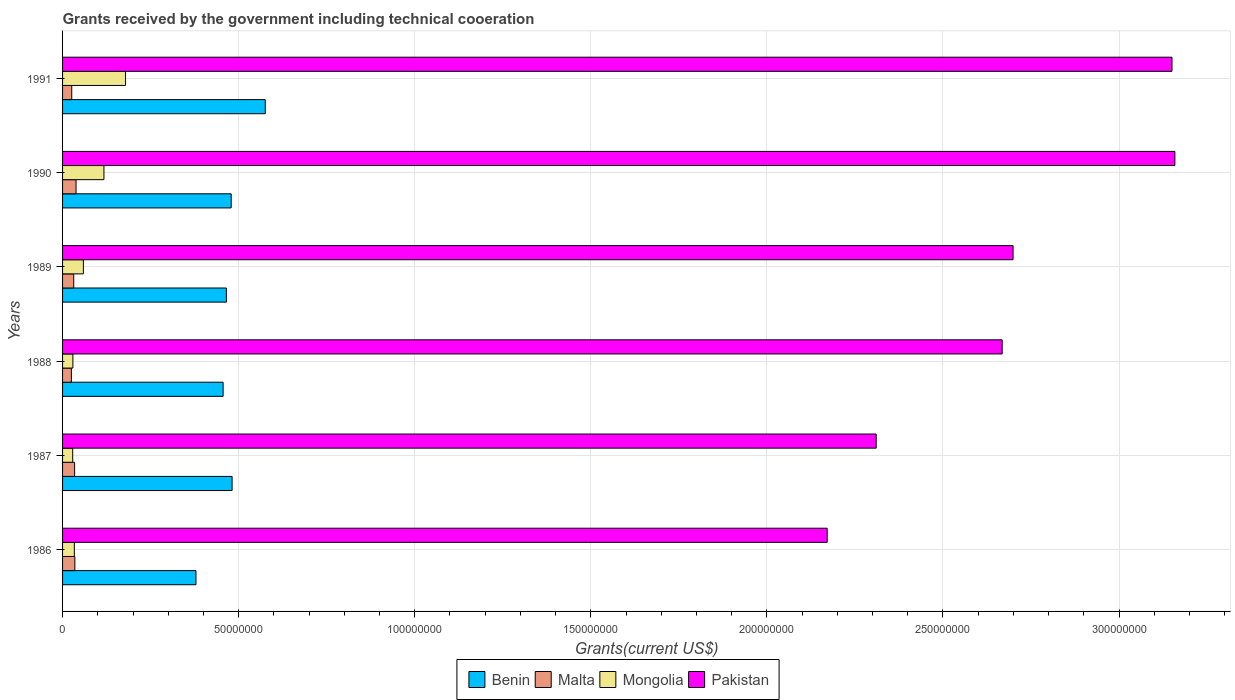How many different coloured bars are there?
Offer a terse response. 4. Are the number of bars per tick equal to the number of legend labels?
Your response must be concise. Yes. How many bars are there on the 4th tick from the top?
Make the answer very short. 4. In how many cases, is the number of bars for a given year not equal to the number of legend labels?
Your response must be concise. 0. What is the total grants received by the government in Pakistan in 1989?
Give a very brief answer. 2.70e+08. Across all years, what is the maximum total grants received by the government in Pakistan?
Ensure brevity in your answer.  3.16e+08. Across all years, what is the minimum total grants received by the government in Malta?
Ensure brevity in your answer.  2.50e+06. In which year was the total grants received by the government in Mongolia minimum?
Keep it short and to the point. 1987. What is the total total grants received by the government in Pakistan in the graph?
Give a very brief answer. 1.62e+09. What is the difference between the total grants received by the government in Benin in 1988 and that in 1990?
Provide a succinct answer. -2.29e+06. What is the difference between the total grants received by the government in Mongolia in 1987 and the total grants received by the government in Pakistan in 1991?
Provide a succinct answer. -3.12e+08. What is the average total grants received by the government in Benin per year?
Your answer should be compact. 4.73e+07. In the year 1991, what is the difference between the total grants received by the government in Malta and total grants received by the government in Mongolia?
Make the answer very short. -1.53e+07. In how many years, is the total grants received by the government in Benin greater than 230000000 US$?
Your answer should be compact. 0. What is the ratio of the total grants received by the government in Benin in 1988 to that in 1991?
Provide a short and direct response. 0.79. What is the difference between the highest and the second highest total grants received by the government in Mongolia?
Give a very brief answer. 6.13e+06. What is the difference between the highest and the lowest total grants received by the government in Benin?
Offer a terse response. 1.97e+07. Is the sum of the total grants received by the government in Pakistan in 1988 and 1989 greater than the maximum total grants received by the government in Malta across all years?
Offer a terse response. Yes. Is it the case that in every year, the sum of the total grants received by the government in Malta and total grants received by the government in Benin is greater than the sum of total grants received by the government in Pakistan and total grants received by the government in Mongolia?
Offer a very short reply. Yes. What does the 4th bar from the top in 1986 represents?
Ensure brevity in your answer.  Benin. What does the 3rd bar from the bottom in 1988 represents?
Provide a short and direct response. Mongolia. Are the values on the major ticks of X-axis written in scientific E-notation?
Give a very brief answer. No. Does the graph contain grids?
Your response must be concise. Yes. What is the title of the graph?
Your answer should be compact. Grants received by the government including technical cooeration. What is the label or title of the X-axis?
Your answer should be compact. Grants(current US$). What is the Grants(current US$) of Benin in 1986?
Your answer should be very brief. 3.79e+07. What is the Grants(current US$) in Malta in 1986?
Keep it short and to the point. 3.49e+06. What is the Grants(current US$) of Mongolia in 1986?
Ensure brevity in your answer.  3.34e+06. What is the Grants(current US$) of Pakistan in 1986?
Your answer should be very brief. 2.17e+08. What is the Grants(current US$) of Benin in 1987?
Keep it short and to the point. 4.81e+07. What is the Grants(current US$) in Malta in 1987?
Ensure brevity in your answer.  3.42e+06. What is the Grants(current US$) of Mongolia in 1987?
Your response must be concise. 2.88e+06. What is the Grants(current US$) in Pakistan in 1987?
Offer a very short reply. 2.31e+08. What is the Grants(current US$) of Benin in 1988?
Offer a very short reply. 4.56e+07. What is the Grants(current US$) in Malta in 1988?
Your answer should be compact. 2.50e+06. What is the Grants(current US$) of Mongolia in 1988?
Provide a succinct answer. 2.93e+06. What is the Grants(current US$) in Pakistan in 1988?
Your answer should be compact. 2.67e+08. What is the Grants(current US$) of Benin in 1989?
Ensure brevity in your answer.  4.65e+07. What is the Grants(current US$) in Malta in 1989?
Your answer should be compact. 3.17e+06. What is the Grants(current US$) in Mongolia in 1989?
Give a very brief answer. 5.91e+06. What is the Grants(current US$) of Pakistan in 1989?
Provide a short and direct response. 2.70e+08. What is the Grants(current US$) in Benin in 1990?
Give a very brief answer. 4.79e+07. What is the Grants(current US$) in Malta in 1990?
Make the answer very short. 3.83e+06. What is the Grants(current US$) of Mongolia in 1990?
Give a very brief answer. 1.18e+07. What is the Grants(current US$) of Pakistan in 1990?
Provide a succinct answer. 3.16e+08. What is the Grants(current US$) in Benin in 1991?
Offer a terse response. 5.76e+07. What is the Grants(current US$) of Malta in 1991?
Your answer should be very brief. 2.61e+06. What is the Grants(current US$) of Mongolia in 1991?
Make the answer very short. 1.79e+07. What is the Grants(current US$) of Pakistan in 1991?
Offer a terse response. 3.15e+08. Across all years, what is the maximum Grants(current US$) of Benin?
Provide a short and direct response. 5.76e+07. Across all years, what is the maximum Grants(current US$) in Malta?
Offer a terse response. 3.83e+06. Across all years, what is the maximum Grants(current US$) of Mongolia?
Your response must be concise. 1.79e+07. Across all years, what is the maximum Grants(current US$) of Pakistan?
Give a very brief answer. 3.16e+08. Across all years, what is the minimum Grants(current US$) in Benin?
Provide a short and direct response. 3.79e+07. Across all years, what is the minimum Grants(current US$) of Malta?
Make the answer very short. 2.50e+06. Across all years, what is the minimum Grants(current US$) of Mongolia?
Keep it short and to the point. 2.88e+06. Across all years, what is the minimum Grants(current US$) in Pakistan?
Provide a short and direct response. 2.17e+08. What is the total Grants(current US$) of Benin in the graph?
Provide a short and direct response. 2.84e+08. What is the total Grants(current US$) in Malta in the graph?
Make the answer very short. 1.90e+07. What is the total Grants(current US$) in Mongolia in the graph?
Offer a terse response. 4.47e+07. What is the total Grants(current US$) in Pakistan in the graph?
Give a very brief answer. 1.62e+09. What is the difference between the Grants(current US$) in Benin in 1986 and that in 1987?
Make the answer very short. -1.03e+07. What is the difference between the Grants(current US$) of Malta in 1986 and that in 1987?
Ensure brevity in your answer.  7.00e+04. What is the difference between the Grants(current US$) in Mongolia in 1986 and that in 1987?
Provide a short and direct response. 4.60e+05. What is the difference between the Grants(current US$) of Pakistan in 1986 and that in 1987?
Keep it short and to the point. -1.39e+07. What is the difference between the Grants(current US$) in Benin in 1986 and that in 1988?
Your answer should be compact. -7.71e+06. What is the difference between the Grants(current US$) in Malta in 1986 and that in 1988?
Offer a terse response. 9.90e+05. What is the difference between the Grants(current US$) of Pakistan in 1986 and that in 1988?
Make the answer very short. -4.97e+07. What is the difference between the Grants(current US$) of Benin in 1986 and that in 1989?
Offer a very short reply. -8.63e+06. What is the difference between the Grants(current US$) in Mongolia in 1986 and that in 1989?
Offer a very short reply. -2.57e+06. What is the difference between the Grants(current US$) of Pakistan in 1986 and that in 1989?
Your response must be concise. -5.28e+07. What is the difference between the Grants(current US$) in Benin in 1986 and that in 1990?
Offer a very short reply. -1.00e+07. What is the difference between the Grants(current US$) in Malta in 1986 and that in 1990?
Make the answer very short. -3.40e+05. What is the difference between the Grants(current US$) in Mongolia in 1986 and that in 1990?
Your response must be concise. -8.41e+06. What is the difference between the Grants(current US$) in Pakistan in 1986 and that in 1990?
Your answer should be very brief. -9.87e+07. What is the difference between the Grants(current US$) of Benin in 1986 and that in 1991?
Ensure brevity in your answer.  -1.97e+07. What is the difference between the Grants(current US$) of Malta in 1986 and that in 1991?
Your answer should be compact. 8.80e+05. What is the difference between the Grants(current US$) in Mongolia in 1986 and that in 1991?
Your answer should be very brief. -1.45e+07. What is the difference between the Grants(current US$) of Pakistan in 1986 and that in 1991?
Your answer should be compact. -9.79e+07. What is the difference between the Grants(current US$) of Benin in 1987 and that in 1988?
Keep it short and to the point. 2.55e+06. What is the difference between the Grants(current US$) of Malta in 1987 and that in 1988?
Give a very brief answer. 9.20e+05. What is the difference between the Grants(current US$) of Mongolia in 1987 and that in 1988?
Give a very brief answer. -5.00e+04. What is the difference between the Grants(current US$) of Pakistan in 1987 and that in 1988?
Offer a very short reply. -3.58e+07. What is the difference between the Grants(current US$) in Benin in 1987 and that in 1989?
Keep it short and to the point. 1.63e+06. What is the difference between the Grants(current US$) in Malta in 1987 and that in 1989?
Provide a short and direct response. 2.50e+05. What is the difference between the Grants(current US$) of Mongolia in 1987 and that in 1989?
Give a very brief answer. -3.03e+06. What is the difference between the Grants(current US$) in Pakistan in 1987 and that in 1989?
Offer a terse response. -3.89e+07. What is the difference between the Grants(current US$) of Benin in 1987 and that in 1990?
Offer a terse response. 2.60e+05. What is the difference between the Grants(current US$) of Malta in 1987 and that in 1990?
Your answer should be compact. -4.10e+05. What is the difference between the Grants(current US$) of Mongolia in 1987 and that in 1990?
Provide a short and direct response. -8.87e+06. What is the difference between the Grants(current US$) in Pakistan in 1987 and that in 1990?
Offer a very short reply. -8.48e+07. What is the difference between the Grants(current US$) in Benin in 1987 and that in 1991?
Your answer should be very brief. -9.42e+06. What is the difference between the Grants(current US$) of Malta in 1987 and that in 1991?
Keep it short and to the point. 8.10e+05. What is the difference between the Grants(current US$) of Mongolia in 1987 and that in 1991?
Provide a succinct answer. -1.50e+07. What is the difference between the Grants(current US$) of Pakistan in 1987 and that in 1991?
Provide a short and direct response. -8.40e+07. What is the difference between the Grants(current US$) of Benin in 1988 and that in 1989?
Ensure brevity in your answer.  -9.20e+05. What is the difference between the Grants(current US$) in Malta in 1988 and that in 1989?
Keep it short and to the point. -6.70e+05. What is the difference between the Grants(current US$) in Mongolia in 1988 and that in 1989?
Your response must be concise. -2.98e+06. What is the difference between the Grants(current US$) in Pakistan in 1988 and that in 1989?
Make the answer very short. -3.09e+06. What is the difference between the Grants(current US$) in Benin in 1988 and that in 1990?
Ensure brevity in your answer.  -2.29e+06. What is the difference between the Grants(current US$) of Malta in 1988 and that in 1990?
Offer a terse response. -1.33e+06. What is the difference between the Grants(current US$) of Mongolia in 1988 and that in 1990?
Your answer should be compact. -8.82e+06. What is the difference between the Grants(current US$) in Pakistan in 1988 and that in 1990?
Your answer should be very brief. -4.90e+07. What is the difference between the Grants(current US$) of Benin in 1988 and that in 1991?
Offer a terse response. -1.20e+07. What is the difference between the Grants(current US$) in Malta in 1988 and that in 1991?
Keep it short and to the point. -1.10e+05. What is the difference between the Grants(current US$) in Mongolia in 1988 and that in 1991?
Your answer should be compact. -1.50e+07. What is the difference between the Grants(current US$) in Pakistan in 1988 and that in 1991?
Your answer should be compact. -4.82e+07. What is the difference between the Grants(current US$) in Benin in 1989 and that in 1990?
Provide a short and direct response. -1.37e+06. What is the difference between the Grants(current US$) in Malta in 1989 and that in 1990?
Make the answer very short. -6.60e+05. What is the difference between the Grants(current US$) in Mongolia in 1989 and that in 1990?
Offer a very short reply. -5.84e+06. What is the difference between the Grants(current US$) in Pakistan in 1989 and that in 1990?
Provide a short and direct response. -4.60e+07. What is the difference between the Grants(current US$) of Benin in 1989 and that in 1991?
Provide a succinct answer. -1.10e+07. What is the difference between the Grants(current US$) in Malta in 1989 and that in 1991?
Offer a very short reply. 5.60e+05. What is the difference between the Grants(current US$) in Mongolia in 1989 and that in 1991?
Offer a very short reply. -1.20e+07. What is the difference between the Grants(current US$) in Pakistan in 1989 and that in 1991?
Offer a very short reply. -4.51e+07. What is the difference between the Grants(current US$) in Benin in 1990 and that in 1991?
Make the answer very short. -9.68e+06. What is the difference between the Grants(current US$) in Malta in 1990 and that in 1991?
Your answer should be compact. 1.22e+06. What is the difference between the Grants(current US$) in Mongolia in 1990 and that in 1991?
Your answer should be compact. -6.13e+06. What is the difference between the Grants(current US$) in Pakistan in 1990 and that in 1991?
Give a very brief answer. 8.20e+05. What is the difference between the Grants(current US$) of Benin in 1986 and the Grants(current US$) of Malta in 1987?
Make the answer very short. 3.45e+07. What is the difference between the Grants(current US$) of Benin in 1986 and the Grants(current US$) of Mongolia in 1987?
Make the answer very short. 3.50e+07. What is the difference between the Grants(current US$) in Benin in 1986 and the Grants(current US$) in Pakistan in 1987?
Provide a short and direct response. -1.93e+08. What is the difference between the Grants(current US$) in Malta in 1986 and the Grants(current US$) in Mongolia in 1987?
Your response must be concise. 6.10e+05. What is the difference between the Grants(current US$) of Malta in 1986 and the Grants(current US$) of Pakistan in 1987?
Provide a succinct answer. -2.28e+08. What is the difference between the Grants(current US$) in Mongolia in 1986 and the Grants(current US$) in Pakistan in 1987?
Ensure brevity in your answer.  -2.28e+08. What is the difference between the Grants(current US$) of Benin in 1986 and the Grants(current US$) of Malta in 1988?
Provide a short and direct response. 3.54e+07. What is the difference between the Grants(current US$) of Benin in 1986 and the Grants(current US$) of Mongolia in 1988?
Provide a succinct answer. 3.50e+07. What is the difference between the Grants(current US$) of Benin in 1986 and the Grants(current US$) of Pakistan in 1988?
Provide a short and direct response. -2.29e+08. What is the difference between the Grants(current US$) of Malta in 1986 and the Grants(current US$) of Mongolia in 1988?
Your answer should be very brief. 5.60e+05. What is the difference between the Grants(current US$) in Malta in 1986 and the Grants(current US$) in Pakistan in 1988?
Offer a terse response. -2.63e+08. What is the difference between the Grants(current US$) of Mongolia in 1986 and the Grants(current US$) of Pakistan in 1988?
Make the answer very short. -2.63e+08. What is the difference between the Grants(current US$) in Benin in 1986 and the Grants(current US$) in Malta in 1989?
Offer a very short reply. 3.47e+07. What is the difference between the Grants(current US$) of Benin in 1986 and the Grants(current US$) of Mongolia in 1989?
Offer a very short reply. 3.20e+07. What is the difference between the Grants(current US$) of Benin in 1986 and the Grants(current US$) of Pakistan in 1989?
Provide a succinct answer. -2.32e+08. What is the difference between the Grants(current US$) of Malta in 1986 and the Grants(current US$) of Mongolia in 1989?
Give a very brief answer. -2.42e+06. What is the difference between the Grants(current US$) in Malta in 1986 and the Grants(current US$) in Pakistan in 1989?
Provide a short and direct response. -2.66e+08. What is the difference between the Grants(current US$) in Mongolia in 1986 and the Grants(current US$) in Pakistan in 1989?
Your answer should be compact. -2.67e+08. What is the difference between the Grants(current US$) of Benin in 1986 and the Grants(current US$) of Malta in 1990?
Offer a very short reply. 3.40e+07. What is the difference between the Grants(current US$) of Benin in 1986 and the Grants(current US$) of Mongolia in 1990?
Provide a succinct answer. 2.61e+07. What is the difference between the Grants(current US$) of Benin in 1986 and the Grants(current US$) of Pakistan in 1990?
Ensure brevity in your answer.  -2.78e+08. What is the difference between the Grants(current US$) in Malta in 1986 and the Grants(current US$) in Mongolia in 1990?
Ensure brevity in your answer.  -8.26e+06. What is the difference between the Grants(current US$) of Malta in 1986 and the Grants(current US$) of Pakistan in 1990?
Offer a terse response. -3.12e+08. What is the difference between the Grants(current US$) of Mongolia in 1986 and the Grants(current US$) of Pakistan in 1990?
Your response must be concise. -3.13e+08. What is the difference between the Grants(current US$) of Benin in 1986 and the Grants(current US$) of Malta in 1991?
Your response must be concise. 3.53e+07. What is the difference between the Grants(current US$) in Benin in 1986 and the Grants(current US$) in Mongolia in 1991?
Your answer should be compact. 2.00e+07. What is the difference between the Grants(current US$) in Benin in 1986 and the Grants(current US$) in Pakistan in 1991?
Give a very brief answer. -2.77e+08. What is the difference between the Grants(current US$) of Malta in 1986 and the Grants(current US$) of Mongolia in 1991?
Give a very brief answer. -1.44e+07. What is the difference between the Grants(current US$) in Malta in 1986 and the Grants(current US$) in Pakistan in 1991?
Provide a short and direct response. -3.12e+08. What is the difference between the Grants(current US$) of Mongolia in 1986 and the Grants(current US$) of Pakistan in 1991?
Give a very brief answer. -3.12e+08. What is the difference between the Grants(current US$) of Benin in 1987 and the Grants(current US$) of Malta in 1988?
Your answer should be compact. 4.56e+07. What is the difference between the Grants(current US$) in Benin in 1987 and the Grants(current US$) in Mongolia in 1988?
Your answer should be compact. 4.52e+07. What is the difference between the Grants(current US$) of Benin in 1987 and the Grants(current US$) of Pakistan in 1988?
Your answer should be very brief. -2.19e+08. What is the difference between the Grants(current US$) of Malta in 1987 and the Grants(current US$) of Mongolia in 1988?
Give a very brief answer. 4.90e+05. What is the difference between the Grants(current US$) of Malta in 1987 and the Grants(current US$) of Pakistan in 1988?
Give a very brief answer. -2.63e+08. What is the difference between the Grants(current US$) in Mongolia in 1987 and the Grants(current US$) in Pakistan in 1988?
Provide a succinct answer. -2.64e+08. What is the difference between the Grants(current US$) in Benin in 1987 and the Grants(current US$) in Malta in 1989?
Provide a succinct answer. 4.50e+07. What is the difference between the Grants(current US$) in Benin in 1987 and the Grants(current US$) in Mongolia in 1989?
Keep it short and to the point. 4.22e+07. What is the difference between the Grants(current US$) of Benin in 1987 and the Grants(current US$) of Pakistan in 1989?
Offer a terse response. -2.22e+08. What is the difference between the Grants(current US$) in Malta in 1987 and the Grants(current US$) in Mongolia in 1989?
Give a very brief answer. -2.49e+06. What is the difference between the Grants(current US$) in Malta in 1987 and the Grants(current US$) in Pakistan in 1989?
Make the answer very short. -2.66e+08. What is the difference between the Grants(current US$) of Mongolia in 1987 and the Grants(current US$) of Pakistan in 1989?
Provide a succinct answer. -2.67e+08. What is the difference between the Grants(current US$) in Benin in 1987 and the Grants(current US$) in Malta in 1990?
Provide a succinct answer. 4.43e+07. What is the difference between the Grants(current US$) in Benin in 1987 and the Grants(current US$) in Mongolia in 1990?
Give a very brief answer. 3.64e+07. What is the difference between the Grants(current US$) in Benin in 1987 and the Grants(current US$) in Pakistan in 1990?
Make the answer very short. -2.68e+08. What is the difference between the Grants(current US$) of Malta in 1987 and the Grants(current US$) of Mongolia in 1990?
Make the answer very short. -8.33e+06. What is the difference between the Grants(current US$) in Malta in 1987 and the Grants(current US$) in Pakistan in 1990?
Keep it short and to the point. -3.12e+08. What is the difference between the Grants(current US$) of Mongolia in 1987 and the Grants(current US$) of Pakistan in 1990?
Your response must be concise. -3.13e+08. What is the difference between the Grants(current US$) of Benin in 1987 and the Grants(current US$) of Malta in 1991?
Your answer should be compact. 4.55e+07. What is the difference between the Grants(current US$) in Benin in 1987 and the Grants(current US$) in Mongolia in 1991?
Your response must be concise. 3.03e+07. What is the difference between the Grants(current US$) in Benin in 1987 and the Grants(current US$) in Pakistan in 1991?
Give a very brief answer. -2.67e+08. What is the difference between the Grants(current US$) of Malta in 1987 and the Grants(current US$) of Mongolia in 1991?
Provide a succinct answer. -1.45e+07. What is the difference between the Grants(current US$) of Malta in 1987 and the Grants(current US$) of Pakistan in 1991?
Provide a short and direct response. -3.12e+08. What is the difference between the Grants(current US$) of Mongolia in 1987 and the Grants(current US$) of Pakistan in 1991?
Give a very brief answer. -3.12e+08. What is the difference between the Grants(current US$) in Benin in 1988 and the Grants(current US$) in Malta in 1989?
Offer a very short reply. 4.24e+07. What is the difference between the Grants(current US$) in Benin in 1988 and the Grants(current US$) in Mongolia in 1989?
Keep it short and to the point. 3.97e+07. What is the difference between the Grants(current US$) of Benin in 1988 and the Grants(current US$) of Pakistan in 1989?
Offer a terse response. -2.24e+08. What is the difference between the Grants(current US$) of Malta in 1988 and the Grants(current US$) of Mongolia in 1989?
Provide a succinct answer. -3.41e+06. What is the difference between the Grants(current US$) in Malta in 1988 and the Grants(current US$) in Pakistan in 1989?
Your answer should be compact. -2.67e+08. What is the difference between the Grants(current US$) of Mongolia in 1988 and the Grants(current US$) of Pakistan in 1989?
Provide a succinct answer. -2.67e+08. What is the difference between the Grants(current US$) in Benin in 1988 and the Grants(current US$) in Malta in 1990?
Ensure brevity in your answer.  4.18e+07. What is the difference between the Grants(current US$) in Benin in 1988 and the Grants(current US$) in Mongolia in 1990?
Give a very brief answer. 3.38e+07. What is the difference between the Grants(current US$) of Benin in 1988 and the Grants(current US$) of Pakistan in 1990?
Give a very brief answer. -2.70e+08. What is the difference between the Grants(current US$) of Malta in 1988 and the Grants(current US$) of Mongolia in 1990?
Offer a terse response. -9.25e+06. What is the difference between the Grants(current US$) of Malta in 1988 and the Grants(current US$) of Pakistan in 1990?
Keep it short and to the point. -3.13e+08. What is the difference between the Grants(current US$) in Mongolia in 1988 and the Grants(current US$) in Pakistan in 1990?
Provide a short and direct response. -3.13e+08. What is the difference between the Grants(current US$) in Benin in 1988 and the Grants(current US$) in Malta in 1991?
Your answer should be compact. 4.30e+07. What is the difference between the Grants(current US$) of Benin in 1988 and the Grants(current US$) of Mongolia in 1991?
Your answer should be very brief. 2.77e+07. What is the difference between the Grants(current US$) of Benin in 1988 and the Grants(current US$) of Pakistan in 1991?
Ensure brevity in your answer.  -2.69e+08. What is the difference between the Grants(current US$) of Malta in 1988 and the Grants(current US$) of Mongolia in 1991?
Your response must be concise. -1.54e+07. What is the difference between the Grants(current US$) of Malta in 1988 and the Grants(current US$) of Pakistan in 1991?
Provide a short and direct response. -3.13e+08. What is the difference between the Grants(current US$) of Mongolia in 1988 and the Grants(current US$) of Pakistan in 1991?
Make the answer very short. -3.12e+08. What is the difference between the Grants(current US$) in Benin in 1989 and the Grants(current US$) in Malta in 1990?
Ensure brevity in your answer.  4.27e+07. What is the difference between the Grants(current US$) of Benin in 1989 and the Grants(current US$) of Mongolia in 1990?
Your answer should be very brief. 3.48e+07. What is the difference between the Grants(current US$) of Benin in 1989 and the Grants(current US$) of Pakistan in 1990?
Your answer should be very brief. -2.69e+08. What is the difference between the Grants(current US$) in Malta in 1989 and the Grants(current US$) in Mongolia in 1990?
Offer a terse response. -8.58e+06. What is the difference between the Grants(current US$) of Malta in 1989 and the Grants(current US$) of Pakistan in 1990?
Keep it short and to the point. -3.13e+08. What is the difference between the Grants(current US$) in Mongolia in 1989 and the Grants(current US$) in Pakistan in 1990?
Ensure brevity in your answer.  -3.10e+08. What is the difference between the Grants(current US$) in Benin in 1989 and the Grants(current US$) in Malta in 1991?
Make the answer very short. 4.39e+07. What is the difference between the Grants(current US$) of Benin in 1989 and the Grants(current US$) of Mongolia in 1991?
Your response must be concise. 2.86e+07. What is the difference between the Grants(current US$) in Benin in 1989 and the Grants(current US$) in Pakistan in 1991?
Your answer should be very brief. -2.69e+08. What is the difference between the Grants(current US$) of Malta in 1989 and the Grants(current US$) of Mongolia in 1991?
Your answer should be very brief. -1.47e+07. What is the difference between the Grants(current US$) in Malta in 1989 and the Grants(current US$) in Pakistan in 1991?
Your answer should be very brief. -3.12e+08. What is the difference between the Grants(current US$) in Mongolia in 1989 and the Grants(current US$) in Pakistan in 1991?
Offer a very short reply. -3.09e+08. What is the difference between the Grants(current US$) of Benin in 1990 and the Grants(current US$) of Malta in 1991?
Provide a succinct answer. 4.53e+07. What is the difference between the Grants(current US$) of Benin in 1990 and the Grants(current US$) of Mongolia in 1991?
Offer a terse response. 3.00e+07. What is the difference between the Grants(current US$) in Benin in 1990 and the Grants(current US$) in Pakistan in 1991?
Ensure brevity in your answer.  -2.67e+08. What is the difference between the Grants(current US$) in Malta in 1990 and the Grants(current US$) in Mongolia in 1991?
Give a very brief answer. -1.40e+07. What is the difference between the Grants(current US$) of Malta in 1990 and the Grants(current US$) of Pakistan in 1991?
Offer a very short reply. -3.11e+08. What is the difference between the Grants(current US$) in Mongolia in 1990 and the Grants(current US$) in Pakistan in 1991?
Give a very brief answer. -3.03e+08. What is the average Grants(current US$) of Benin per year?
Offer a terse response. 4.73e+07. What is the average Grants(current US$) of Malta per year?
Offer a very short reply. 3.17e+06. What is the average Grants(current US$) in Mongolia per year?
Offer a very short reply. 7.45e+06. What is the average Grants(current US$) of Pakistan per year?
Give a very brief answer. 2.69e+08. In the year 1986, what is the difference between the Grants(current US$) of Benin and Grants(current US$) of Malta?
Ensure brevity in your answer.  3.44e+07. In the year 1986, what is the difference between the Grants(current US$) of Benin and Grants(current US$) of Mongolia?
Your response must be concise. 3.45e+07. In the year 1986, what is the difference between the Grants(current US$) of Benin and Grants(current US$) of Pakistan?
Give a very brief answer. -1.79e+08. In the year 1986, what is the difference between the Grants(current US$) in Malta and Grants(current US$) in Pakistan?
Your answer should be very brief. -2.14e+08. In the year 1986, what is the difference between the Grants(current US$) in Mongolia and Grants(current US$) in Pakistan?
Give a very brief answer. -2.14e+08. In the year 1987, what is the difference between the Grants(current US$) of Benin and Grants(current US$) of Malta?
Make the answer very short. 4.47e+07. In the year 1987, what is the difference between the Grants(current US$) in Benin and Grants(current US$) in Mongolia?
Your answer should be very brief. 4.53e+07. In the year 1987, what is the difference between the Grants(current US$) of Benin and Grants(current US$) of Pakistan?
Your answer should be compact. -1.83e+08. In the year 1987, what is the difference between the Grants(current US$) of Malta and Grants(current US$) of Mongolia?
Provide a succinct answer. 5.40e+05. In the year 1987, what is the difference between the Grants(current US$) in Malta and Grants(current US$) in Pakistan?
Offer a terse response. -2.28e+08. In the year 1987, what is the difference between the Grants(current US$) in Mongolia and Grants(current US$) in Pakistan?
Provide a short and direct response. -2.28e+08. In the year 1988, what is the difference between the Grants(current US$) in Benin and Grants(current US$) in Malta?
Provide a short and direct response. 4.31e+07. In the year 1988, what is the difference between the Grants(current US$) of Benin and Grants(current US$) of Mongolia?
Your response must be concise. 4.27e+07. In the year 1988, what is the difference between the Grants(current US$) of Benin and Grants(current US$) of Pakistan?
Offer a very short reply. -2.21e+08. In the year 1988, what is the difference between the Grants(current US$) of Malta and Grants(current US$) of Mongolia?
Keep it short and to the point. -4.30e+05. In the year 1988, what is the difference between the Grants(current US$) in Malta and Grants(current US$) in Pakistan?
Give a very brief answer. -2.64e+08. In the year 1988, what is the difference between the Grants(current US$) of Mongolia and Grants(current US$) of Pakistan?
Your answer should be compact. -2.64e+08. In the year 1989, what is the difference between the Grants(current US$) of Benin and Grants(current US$) of Malta?
Your answer should be compact. 4.33e+07. In the year 1989, what is the difference between the Grants(current US$) of Benin and Grants(current US$) of Mongolia?
Provide a short and direct response. 4.06e+07. In the year 1989, what is the difference between the Grants(current US$) of Benin and Grants(current US$) of Pakistan?
Keep it short and to the point. -2.23e+08. In the year 1989, what is the difference between the Grants(current US$) of Malta and Grants(current US$) of Mongolia?
Keep it short and to the point. -2.74e+06. In the year 1989, what is the difference between the Grants(current US$) in Malta and Grants(current US$) in Pakistan?
Offer a terse response. -2.67e+08. In the year 1989, what is the difference between the Grants(current US$) of Mongolia and Grants(current US$) of Pakistan?
Make the answer very short. -2.64e+08. In the year 1990, what is the difference between the Grants(current US$) in Benin and Grants(current US$) in Malta?
Keep it short and to the point. 4.40e+07. In the year 1990, what is the difference between the Grants(current US$) in Benin and Grants(current US$) in Mongolia?
Offer a very short reply. 3.61e+07. In the year 1990, what is the difference between the Grants(current US$) in Benin and Grants(current US$) in Pakistan?
Keep it short and to the point. -2.68e+08. In the year 1990, what is the difference between the Grants(current US$) in Malta and Grants(current US$) in Mongolia?
Offer a terse response. -7.92e+06. In the year 1990, what is the difference between the Grants(current US$) of Malta and Grants(current US$) of Pakistan?
Your response must be concise. -3.12e+08. In the year 1990, what is the difference between the Grants(current US$) in Mongolia and Grants(current US$) in Pakistan?
Provide a succinct answer. -3.04e+08. In the year 1991, what is the difference between the Grants(current US$) in Benin and Grants(current US$) in Malta?
Your response must be concise. 5.50e+07. In the year 1991, what is the difference between the Grants(current US$) of Benin and Grants(current US$) of Mongolia?
Give a very brief answer. 3.97e+07. In the year 1991, what is the difference between the Grants(current US$) in Benin and Grants(current US$) in Pakistan?
Provide a short and direct response. -2.57e+08. In the year 1991, what is the difference between the Grants(current US$) in Malta and Grants(current US$) in Mongolia?
Provide a short and direct response. -1.53e+07. In the year 1991, what is the difference between the Grants(current US$) in Malta and Grants(current US$) in Pakistan?
Give a very brief answer. -3.12e+08. In the year 1991, what is the difference between the Grants(current US$) in Mongolia and Grants(current US$) in Pakistan?
Your answer should be very brief. -2.97e+08. What is the ratio of the Grants(current US$) of Benin in 1986 to that in 1987?
Provide a succinct answer. 0.79. What is the ratio of the Grants(current US$) of Malta in 1986 to that in 1987?
Offer a terse response. 1.02. What is the ratio of the Grants(current US$) in Mongolia in 1986 to that in 1987?
Your answer should be very brief. 1.16. What is the ratio of the Grants(current US$) of Pakistan in 1986 to that in 1987?
Offer a terse response. 0.94. What is the ratio of the Grants(current US$) of Benin in 1986 to that in 1988?
Your response must be concise. 0.83. What is the ratio of the Grants(current US$) of Malta in 1986 to that in 1988?
Give a very brief answer. 1.4. What is the ratio of the Grants(current US$) of Mongolia in 1986 to that in 1988?
Your answer should be compact. 1.14. What is the ratio of the Grants(current US$) in Pakistan in 1986 to that in 1988?
Provide a short and direct response. 0.81. What is the ratio of the Grants(current US$) of Benin in 1986 to that in 1989?
Ensure brevity in your answer.  0.81. What is the ratio of the Grants(current US$) of Malta in 1986 to that in 1989?
Offer a very short reply. 1.1. What is the ratio of the Grants(current US$) in Mongolia in 1986 to that in 1989?
Provide a succinct answer. 0.57. What is the ratio of the Grants(current US$) in Pakistan in 1986 to that in 1989?
Offer a very short reply. 0.8. What is the ratio of the Grants(current US$) of Benin in 1986 to that in 1990?
Give a very brief answer. 0.79. What is the ratio of the Grants(current US$) of Malta in 1986 to that in 1990?
Provide a short and direct response. 0.91. What is the ratio of the Grants(current US$) in Mongolia in 1986 to that in 1990?
Your answer should be compact. 0.28. What is the ratio of the Grants(current US$) of Pakistan in 1986 to that in 1990?
Your answer should be compact. 0.69. What is the ratio of the Grants(current US$) in Benin in 1986 to that in 1991?
Your answer should be very brief. 0.66. What is the ratio of the Grants(current US$) of Malta in 1986 to that in 1991?
Your answer should be very brief. 1.34. What is the ratio of the Grants(current US$) in Mongolia in 1986 to that in 1991?
Keep it short and to the point. 0.19. What is the ratio of the Grants(current US$) in Pakistan in 1986 to that in 1991?
Offer a very short reply. 0.69. What is the ratio of the Grants(current US$) in Benin in 1987 to that in 1988?
Offer a very short reply. 1.06. What is the ratio of the Grants(current US$) in Malta in 1987 to that in 1988?
Offer a very short reply. 1.37. What is the ratio of the Grants(current US$) in Mongolia in 1987 to that in 1988?
Make the answer very short. 0.98. What is the ratio of the Grants(current US$) in Pakistan in 1987 to that in 1988?
Offer a terse response. 0.87. What is the ratio of the Grants(current US$) in Benin in 1987 to that in 1989?
Your answer should be compact. 1.03. What is the ratio of the Grants(current US$) in Malta in 1987 to that in 1989?
Your answer should be compact. 1.08. What is the ratio of the Grants(current US$) of Mongolia in 1987 to that in 1989?
Provide a short and direct response. 0.49. What is the ratio of the Grants(current US$) of Pakistan in 1987 to that in 1989?
Your response must be concise. 0.86. What is the ratio of the Grants(current US$) in Benin in 1987 to that in 1990?
Ensure brevity in your answer.  1.01. What is the ratio of the Grants(current US$) in Malta in 1987 to that in 1990?
Keep it short and to the point. 0.89. What is the ratio of the Grants(current US$) in Mongolia in 1987 to that in 1990?
Keep it short and to the point. 0.25. What is the ratio of the Grants(current US$) in Pakistan in 1987 to that in 1990?
Give a very brief answer. 0.73. What is the ratio of the Grants(current US$) of Benin in 1987 to that in 1991?
Your answer should be compact. 0.84. What is the ratio of the Grants(current US$) in Malta in 1987 to that in 1991?
Your response must be concise. 1.31. What is the ratio of the Grants(current US$) in Mongolia in 1987 to that in 1991?
Give a very brief answer. 0.16. What is the ratio of the Grants(current US$) of Pakistan in 1987 to that in 1991?
Make the answer very short. 0.73. What is the ratio of the Grants(current US$) in Benin in 1988 to that in 1989?
Your response must be concise. 0.98. What is the ratio of the Grants(current US$) of Malta in 1988 to that in 1989?
Your answer should be very brief. 0.79. What is the ratio of the Grants(current US$) of Mongolia in 1988 to that in 1989?
Provide a short and direct response. 0.5. What is the ratio of the Grants(current US$) of Benin in 1988 to that in 1990?
Offer a very short reply. 0.95. What is the ratio of the Grants(current US$) in Malta in 1988 to that in 1990?
Ensure brevity in your answer.  0.65. What is the ratio of the Grants(current US$) in Mongolia in 1988 to that in 1990?
Keep it short and to the point. 0.25. What is the ratio of the Grants(current US$) in Pakistan in 1988 to that in 1990?
Provide a succinct answer. 0.84. What is the ratio of the Grants(current US$) of Benin in 1988 to that in 1991?
Offer a very short reply. 0.79. What is the ratio of the Grants(current US$) in Malta in 1988 to that in 1991?
Ensure brevity in your answer.  0.96. What is the ratio of the Grants(current US$) of Mongolia in 1988 to that in 1991?
Give a very brief answer. 0.16. What is the ratio of the Grants(current US$) in Pakistan in 1988 to that in 1991?
Your response must be concise. 0.85. What is the ratio of the Grants(current US$) in Benin in 1989 to that in 1990?
Provide a succinct answer. 0.97. What is the ratio of the Grants(current US$) of Malta in 1989 to that in 1990?
Keep it short and to the point. 0.83. What is the ratio of the Grants(current US$) in Mongolia in 1989 to that in 1990?
Provide a succinct answer. 0.5. What is the ratio of the Grants(current US$) in Pakistan in 1989 to that in 1990?
Provide a succinct answer. 0.85. What is the ratio of the Grants(current US$) of Benin in 1989 to that in 1991?
Offer a terse response. 0.81. What is the ratio of the Grants(current US$) in Malta in 1989 to that in 1991?
Make the answer very short. 1.21. What is the ratio of the Grants(current US$) of Mongolia in 1989 to that in 1991?
Keep it short and to the point. 0.33. What is the ratio of the Grants(current US$) in Pakistan in 1989 to that in 1991?
Give a very brief answer. 0.86. What is the ratio of the Grants(current US$) of Benin in 1990 to that in 1991?
Offer a very short reply. 0.83. What is the ratio of the Grants(current US$) of Malta in 1990 to that in 1991?
Provide a succinct answer. 1.47. What is the ratio of the Grants(current US$) in Mongolia in 1990 to that in 1991?
Make the answer very short. 0.66. What is the difference between the highest and the second highest Grants(current US$) in Benin?
Ensure brevity in your answer.  9.42e+06. What is the difference between the highest and the second highest Grants(current US$) of Malta?
Your answer should be very brief. 3.40e+05. What is the difference between the highest and the second highest Grants(current US$) in Mongolia?
Your answer should be compact. 6.13e+06. What is the difference between the highest and the second highest Grants(current US$) of Pakistan?
Provide a succinct answer. 8.20e+05. What is the difference between the highest and the lowest Grants(current US$) in Benin?
Provide a short and direct response. 1.97e+07. What is the difference between the highest and the lowest Grants(current US$) in Malta?
Your answer should be very brief. 1.33e+06. What is the difference between the highest and the lowest Grants(current US$) in Mongolia?
Make the answer very short. 1.50e+07. What is the difference between the highest and the lowest Grants(current US$) of Pakistan?
Provide a short and direct response. 9.87e+07. 